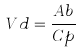Convert formula to latex. <formula><loc_0><loc_0><loc_500><loc_500>V d = \frac { A b } { C p }</formula> 